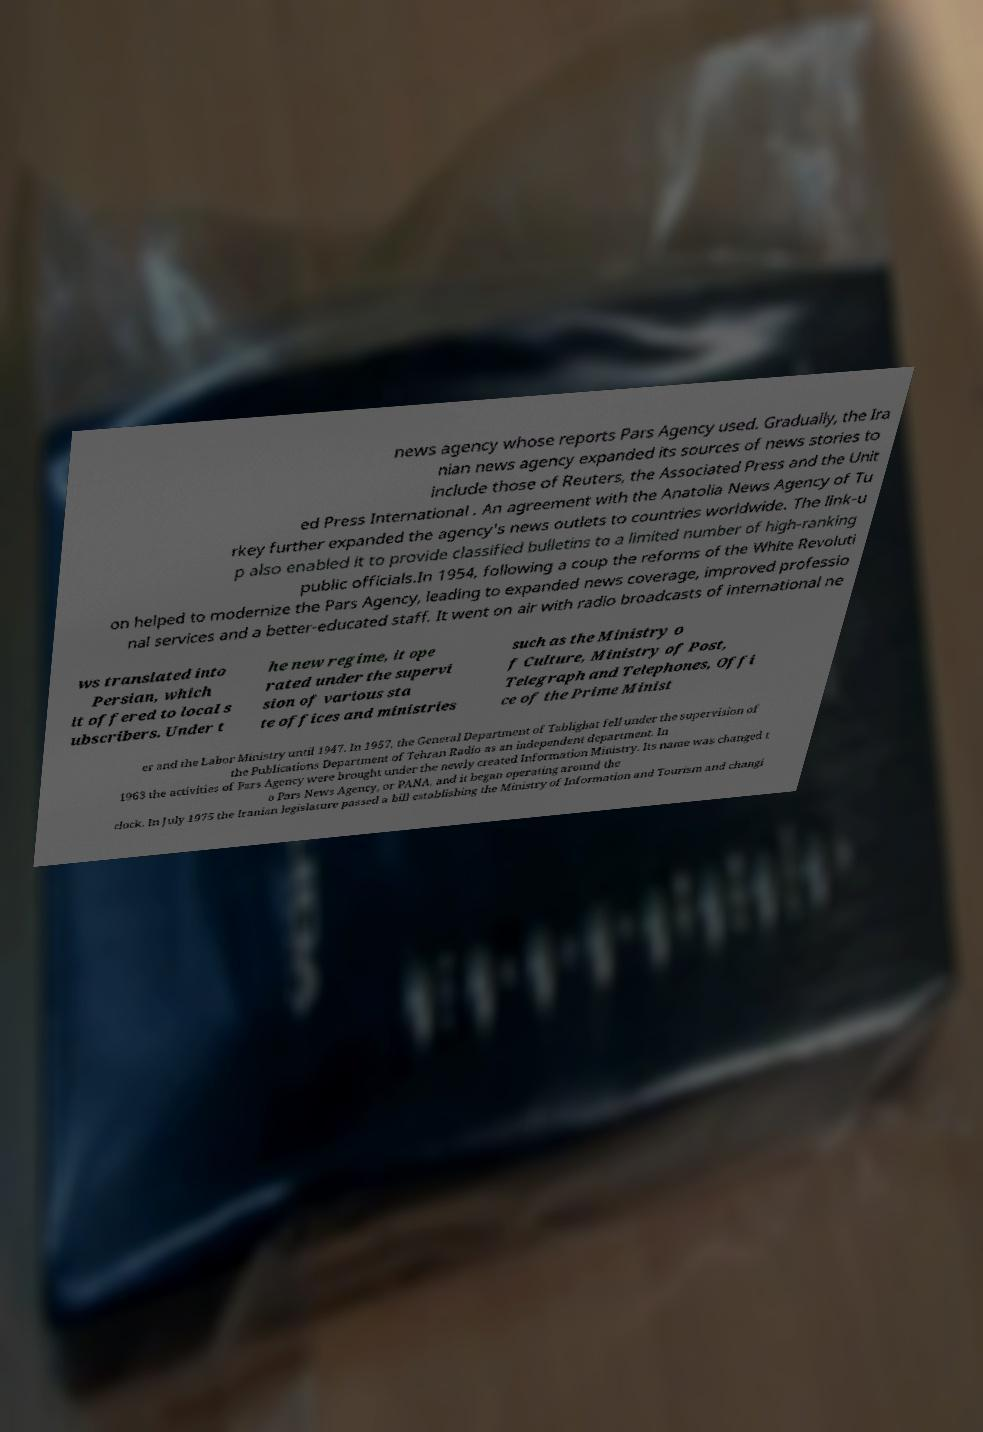Can you read and provide the text displayed in the image?This photo seems to have some interesting text. Can you extract and type it out for me? news agency whose reports Pars Agency used. Gradually, the Ira nian news agency expanded its sources of news stories to include those of Reuters, the Associated Press and the Unit ed Press International . An agreement with the Anatolia News Agency of Tu rkey further expanded the agency's news outlets to countries worldwide. The link-u p also enabled it to provide classified bulletins to a limited number of high-ranking public officials.In 1954, following a coup the reforms of the White Revoluti on helped to modernize the Pars Agency, leading to expanded news coverage, improved professio nal services and a better-educated staff. It went on air with radio broadcasts of international ne ws translated into Persian, which it offered to local s ubscribers. Under t he new regime, it ope rated under the supervi sion of various sta te offices and ministries such as the Ministry o f Culture, Ministry of Post, Telegraph and Telephones, Offi ce of the Prime Minist er and the Labor Ministry until 1947. In 1957, the General Department of Tablighat fell under the supervision of the Publications Department of Tehran Radio as an independent department. In 1963 the activities of Pars Agency were brought under the newly created Information Ministry. Its name was changed t o Pars News Agency, or PANA, and it began operating around the clock. In July 1975 the Iranian legislature passed a bill establishing the Ministry of Information and Tourism and changi 